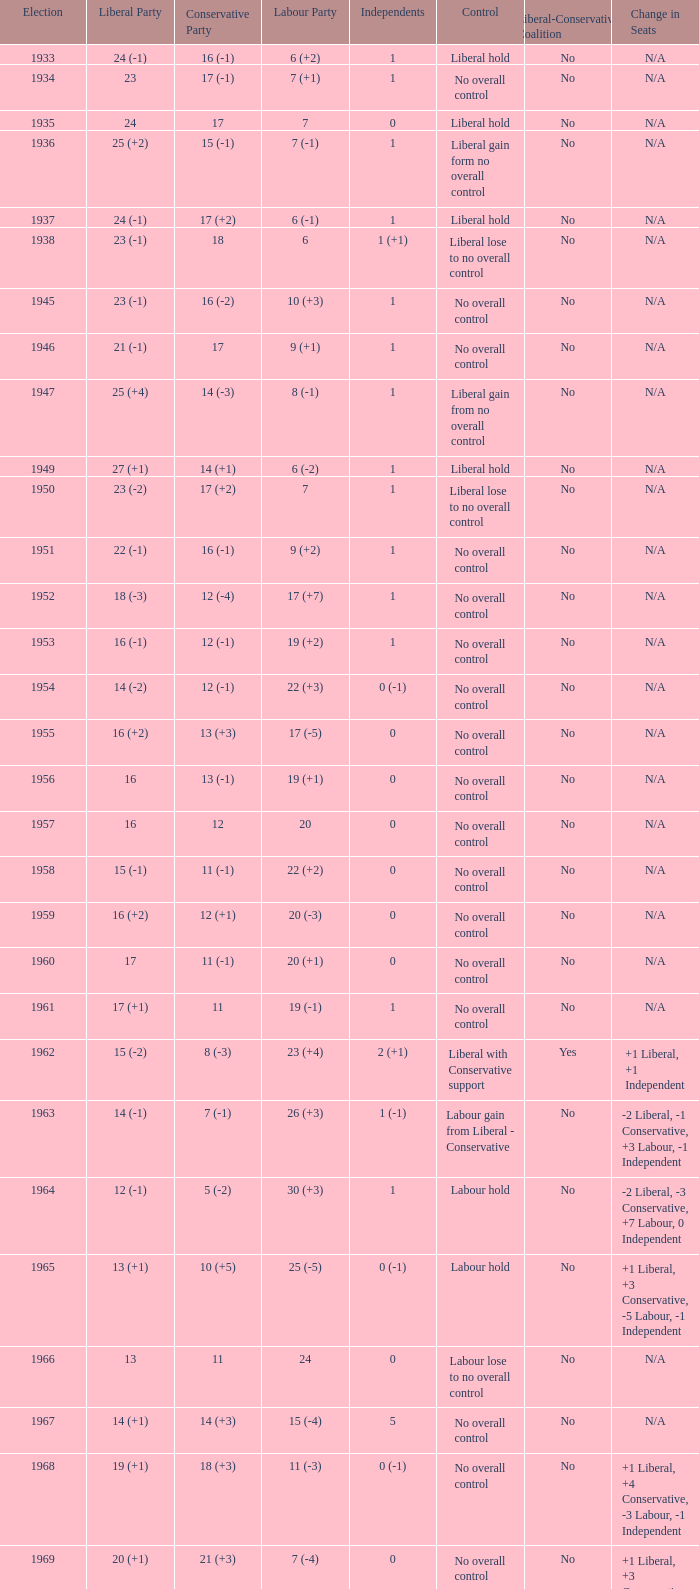What was the Liberal Party result from the election having a Conservative Party result of 16 (-1) and Labour of 6 (+2)? 24 (-1). 